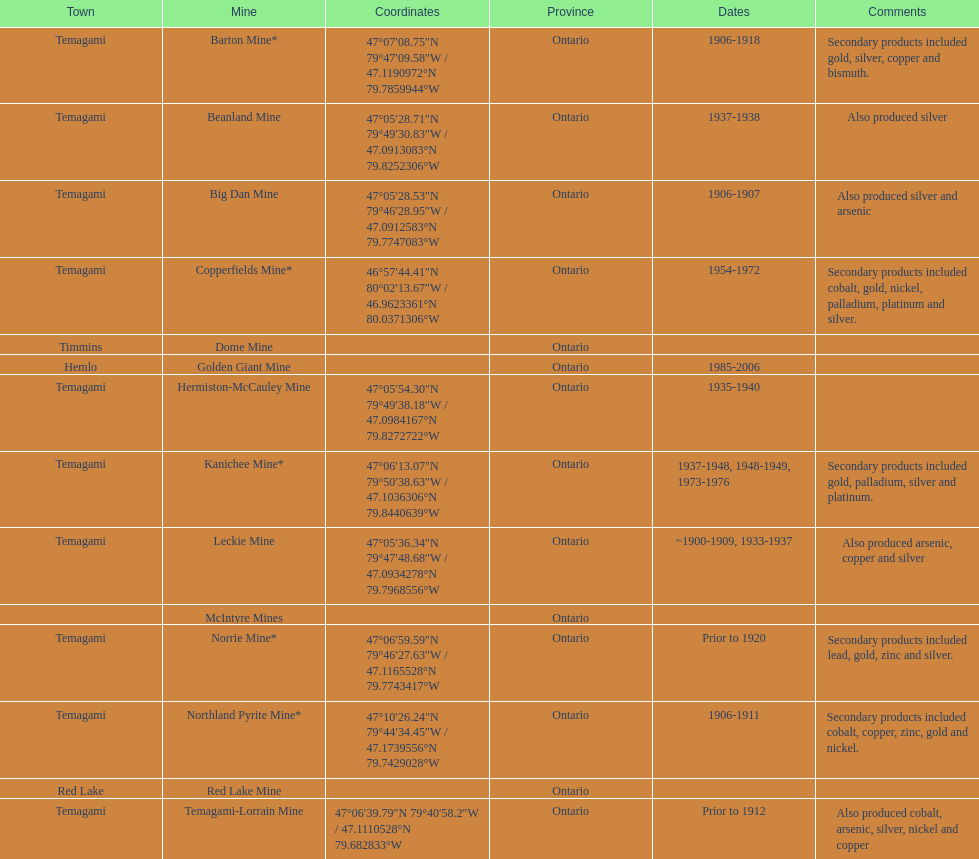Tell me the number of mines that also produced arsenic. 3. 